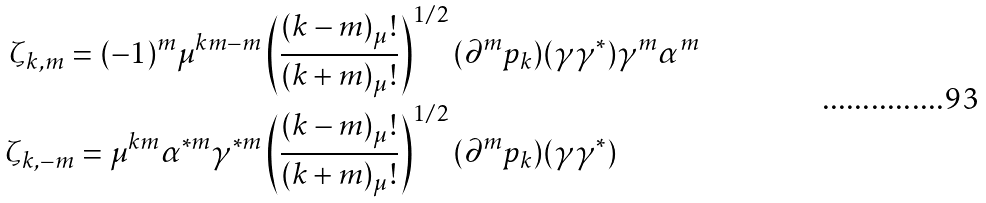Convert formula to latex. <formula><loc_0><loc_0><loc_500><loc_500>\zeta _ { k , m } = ( - 1 ) ^ { m } \mu ^ { k m - m } & \left ( \frac { ( k - m ) _ { \mu } ! } { ( k + m ) _ { \mu } ! } \right ) ^ { 1 / 2 } ( \partial ^ { m } p _ { k } ) ( \gamma \gamma ^ { * } ) \gamma ^ { m } \alpha ^ { m } \\ \zeta _ { k , - m } = \mu ^ { k m } \alpha ^ { * m } \gamma ^ { * m } & \left ( \frac { ( k - m ) _ { \mu } ! } { ( k + m ) _ { \mu } ! } \right ) ^ { 1 / 2 } ( \partial ^ { m } p _ { k } ) ( \gamma \gamma ^ { * } )</formula> 